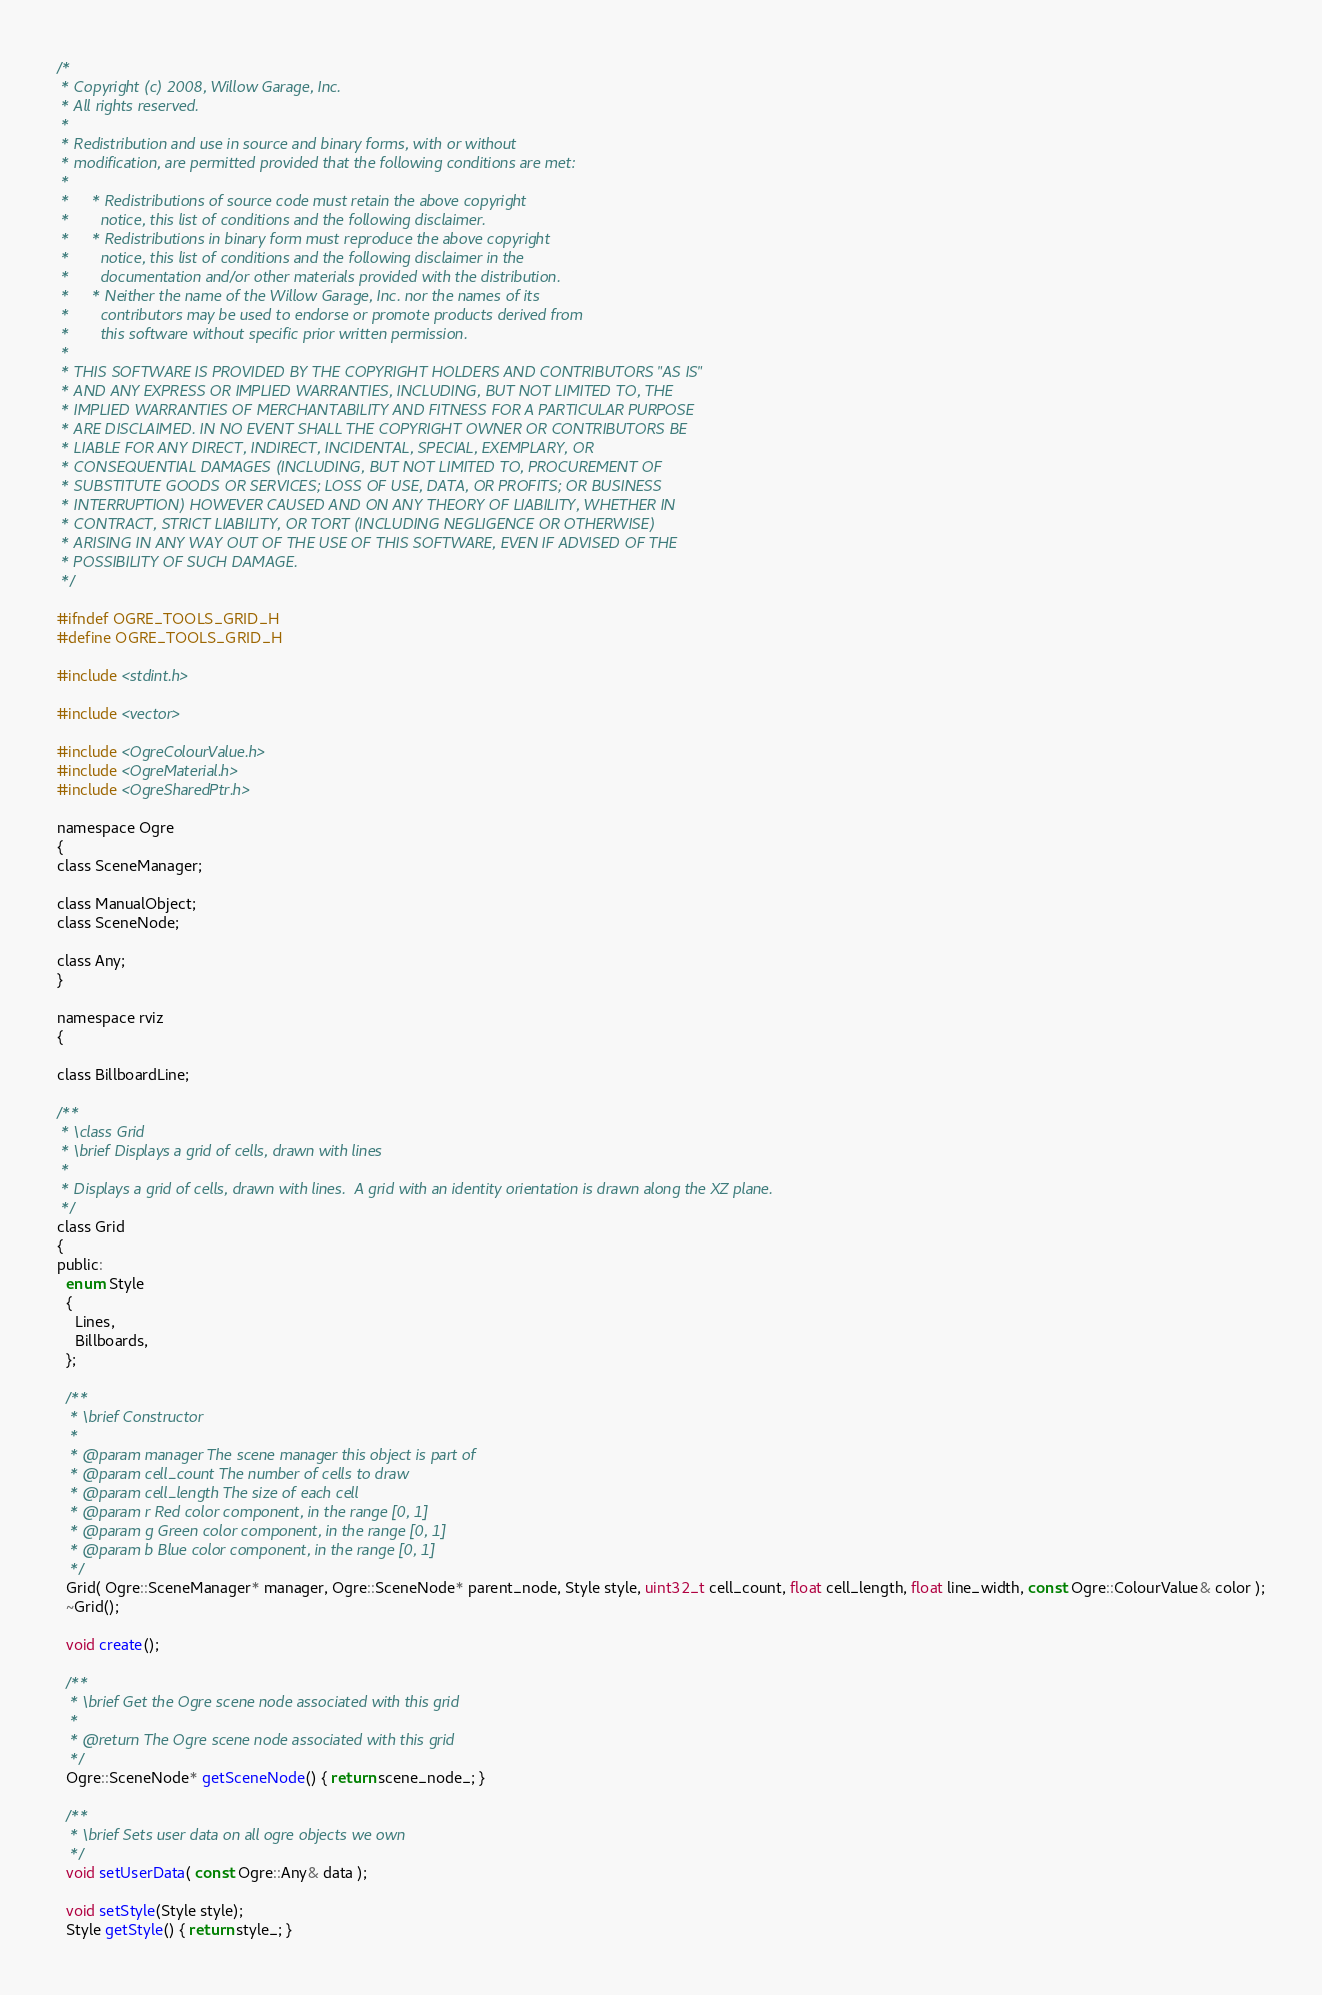<code> <loc_0><loc_0><loc_500><loc_500><_C_>/*
 * Copyright (c) 2008, Willow Garage, Inc.
 * All rights reserved.
 *
 * Redistribution and use in source and binary forms, with or without
 * modification, are permitted provided that the following conditions are met:
 *
 *     * Redistributions of source code must retain the above copyright
 *       notice, this list of conditions and the following disclaimer.
 *     * Redistributions in binary form must reproduce the above copyright
 *       notice, this list of conditions and the following disclaimer in the
 *       documentation and/or other materials provided with the distribution.
 *     * Neither the name of the Willow Garage, Inc. nor the names of its
 *       contributors may be used to endorse or promote products derived from
 *       this software without specific prior written permission.
 *
 * THIS SOFTWARE IS PROVIDED BY THE COPYRIGHT HOLDERS AND CONTRIBUTORS "AS IS"
 * AND ANY EXPRESS OR IMPLIED WARRANTIES, INCLUDING, BUT NOT LIMITED TO, THE
 * IMPLIED WARRANTIES OF MERCHANTABILITY AND FITNESS FOR A PARTICULAR PURPOSE
 * ARE DISCLAIMED. IN NO EVENT SHALL THE COPYRIGHT OWNER OR CONTRIBUTORS BE
 * LIABLE FOR ANY DIRECT, INDIRECT, INCIDENTAL, SPECIAL, EXEMPLARY, OR
 * CONSEQUENTIAL DAMAGES (INCLUDING, BUT NOT LIMITED TO, PROCUREMENT OF
 * SUBSTITUTE GOODS OR SERVICES; LOSS OF USE, DATA, OR PROFITS; OR BUSINESS
 * INTERRUPTION) HOWEVER CAUSED AND ON ANY THEORY OF LIABILITY, WHETHER IN
 * CONTRACT, STRICT LIABILITY, OR TORT (INCLUDING NEGLIGENCE OR OTHERWISE)
 * ARISING IN ANY WAY OUT OF THE USE OF THIS SOFTWARE, EVEN IF ADVISED OF THE
 * POSSIBILITY OF SUCH DAMAGE.
 */

#ifndef OGRE_TOOLS_GRID_H
#define OGRE_TOOLS_GRID_H

#include <stdint.h>

#include <vector>

#include <OgreColourValue.h>
#include <OgreMaterial.h>
#include <OgreSharedPtr.h>

namespace Ogre
{
class SceneManager;

class ManualObject;
class SceneNode;

class Any;
}

namespace rviz
{

class BillboardLine;

/**
 * \class Grid
 * \brief Displays a grid of cells, drawn with lines
 *
 * Displays a grid of cells, drawn with lines.  A grid with an identity orientation is drawn along the XZ plane.
 */
class Grid
{
public:
  enum Style
  {
    Lines,
    Billboards,
  };

  /**
   * \brief Constructor
   *
   * @param manager The scene manager this object is part of
   * @param cell_count The number of cells to draw
   * @param cell_length The size of each cell
   * @param r Red color component, in the range [0, 1]
   * @param g Green color component, in the range [0, 1]
   * @param b Blue color component, in the range [0, 1]
   */
  Grid( Ogre::SceneManager* manager, Ogre::SceneNode* parent_node, Style style, uint32_t cell_count, float cell_length, float line_width, const Ogre::ColourValue& color );
  ~Grid();

  void create();

  /**
   * \brief Get the Ogre scene node associated with this grid
   *
   * @return The Ogre scene node associated with this grid
   */
  Ogre::SceneNode* getSceneNode() { return scene_node_; }

  /**
   * \brief Sets user data on all ogre objects we own
   */
  void setUserData( const Ogre::Any& data );

  void setStyle(Style style);
  Style getStyle() { return style_; }
</code> 